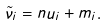Convert formula to latex. <formula><loc_0><loc_0><loc_500><loc_500>\tilde { \nu } _ { i } = n u _ { i } + m _ { i } .</formula> 